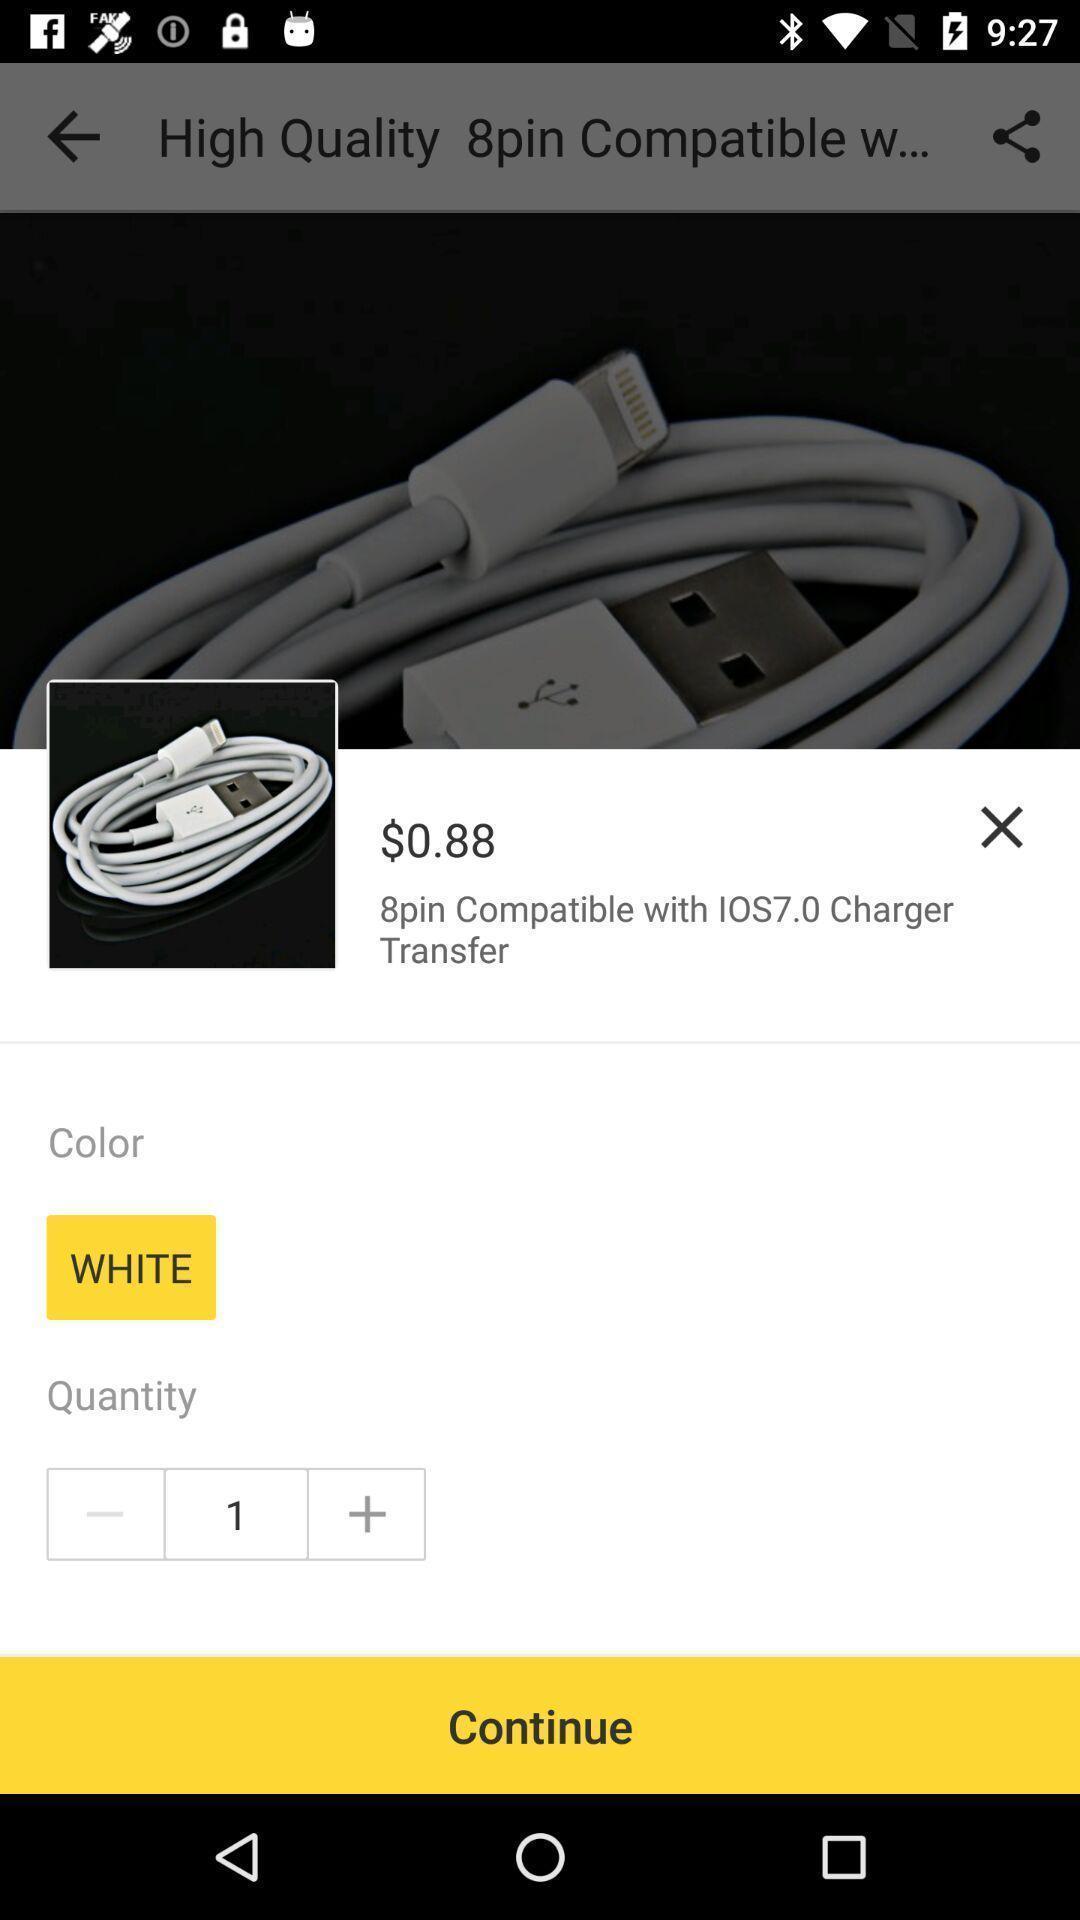Describe this image in words. Screen shows about a product. 